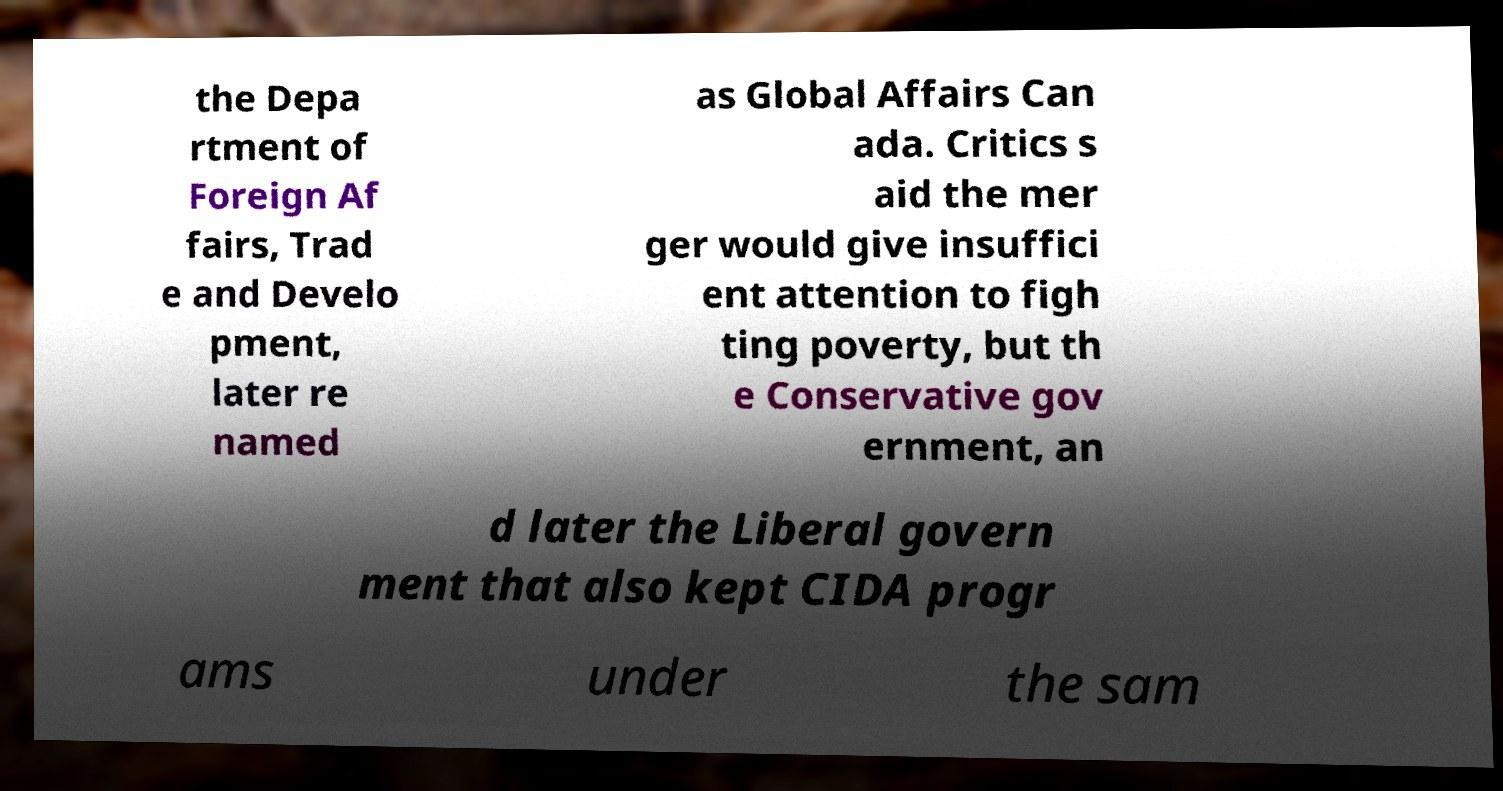There's text embedded in this image that I need extracted. Can you transcribe it verbatim? the Depa rtment of Foreign Af fairs, Trad e and Develo pment, later re named as Global Affairs Can ada. Critics s aid the mer ger would give insuffici ent attention to figh ting poverty, but th e Conservative gov ernment, an d later the Liberal govern ment that also kept CIDA progr ams under the sam 